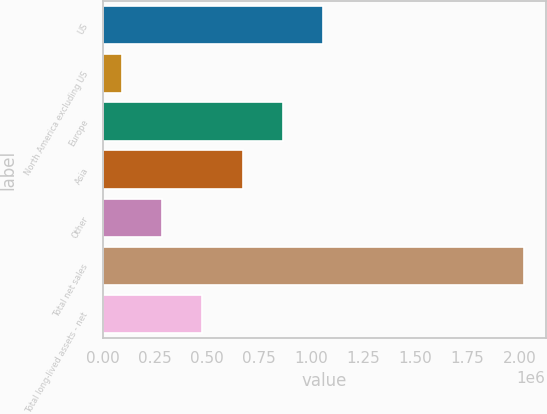Convert chart. <chart><loc_0><loc_0><loc_500><loc_500><bar_chart><fcel>US<fcel>North America excluding US<fcel>Europe<fcel>Asia<fcel>Other<fcel>Total net sales<fcel>Total long-lived assets - net<nl><fcel>1.05617e+06<fcel>88213<fcel>862580<fcel>668988<fcel>281805<fcel>2.02413e+06<fcel>475396<nl></chart> 